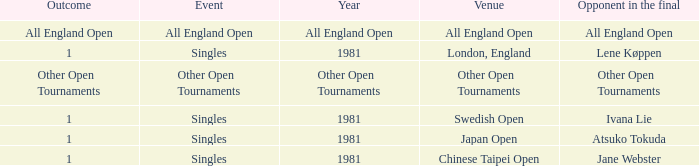What Event has an Outcome of other open tournaments? Other Open Tournaments. 